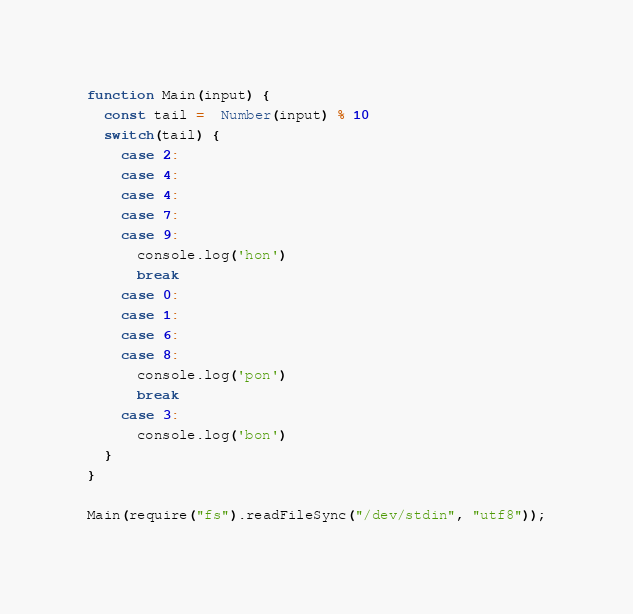Convert code to text. <code><loc_0><loc_0><loc_500><loc_500><_JavaScript_>function Main(input) {
  const tail =  Number(input) % 10
  switch(tail) {
    case 2:
    case 4:
    case 4:
    case 7:
    case 9:
      console.log('hon')
      break
    case 0:
    case 1:
    case 6:
    case 8:
      console.log('pon')
      break
    case 3:
      console.log('bon')
  }
}

Main(require("fs").readFileSync("/dev/stdin", "utf8"));
</code> 